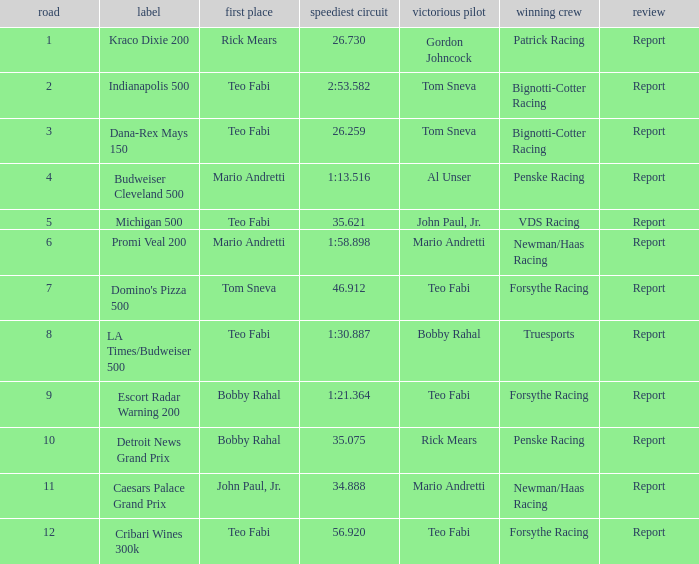How many winning drivers were there in the race that had a fastest lap time of 56.920? 1.0. 